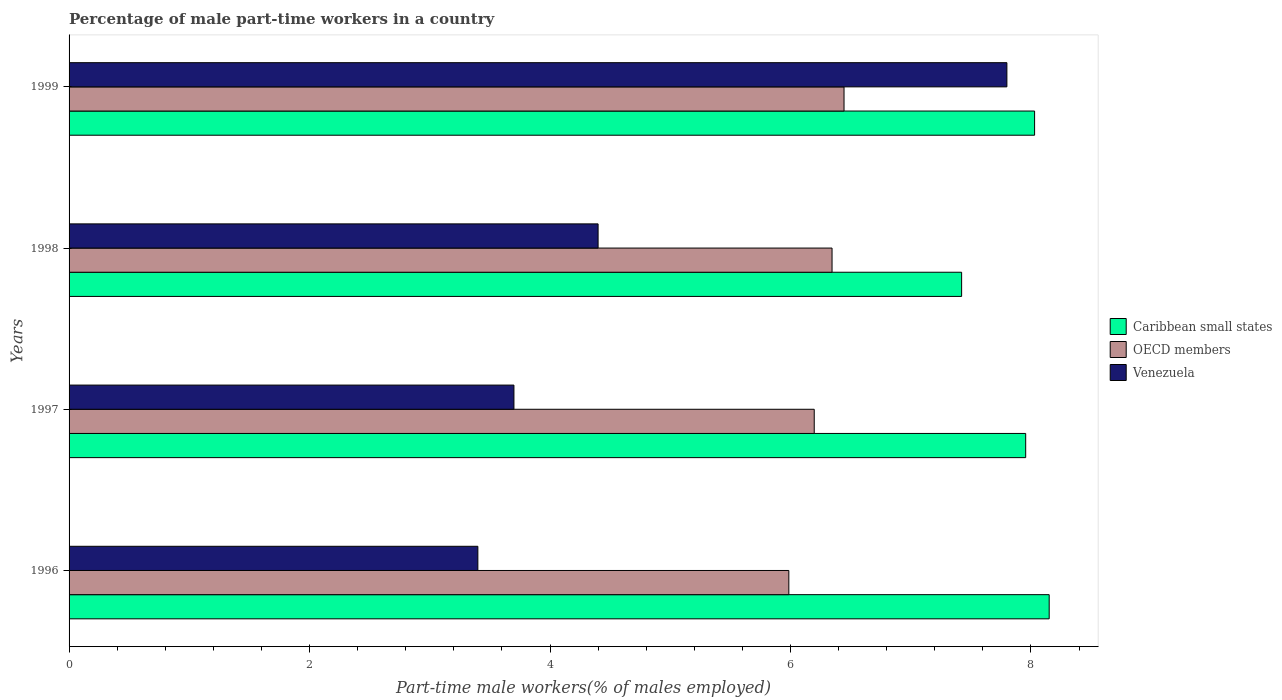How many different coloured bars are there?
Keep it short and to the point. 3. Are the number of bars per tick equal to the number of legend labels?
Your answer should be compact. Yes. How many bars are there on the 3rd tick from the top?
Your answer should be compact. 3. What is the label of the 4th group of bars from the top?
Your response must be concise. 1996. In how many cases, is the number of bars for a given year not equal to the number of legend labels?
Offer a terse response. 0. What is the percentage of male part-time workers in Caribbean small states in 1998?
Your response must be concise. 7.42. Across all years, what is the maximum percentage of male part-time workers in Caribbean small states?
Your answer should be compact. 8.15. Across all years, what is the minimum percentage of male part-time workers in OECD members?
Offer a very short reply. 5.99. In which year was the percentage of male part-time workers in Caribbean small states minimum?
Make the answer very short. 1998. What is the total percentage of male part-time workers in OECD members in the graph?
Your answer should be compact. 24.98. What is the difference between the percentage of male part-time workers in Caribbean small states in 1997 and that in 1999?
Offer a terse response. -0.07. What is the difference between the percentage of male part-time workers in Venezuela in 1997 and the percentage of male part-time workers in OECD members in 1998?
Your answer should be very brief. -2.65. What is the average percentage of male part-time workers in Venezuela per year?
Give a very brief answer. 4.83. In the year 1996, what is the difference between the percentage of male part-time workers in Caribbean small states and percentage of male part-time workers in OECD members?
Provide a succinct answer. 2.17. What is the ratio of the percentage of male part-time workers in Caribbean small states in 1997 to that in 1999?
Ensure brevity in your answer.  0.99. Is the percentage of male part-time workers in OECD members in 1997 less than that in 1999?
Give a very brief answer. Yes. What is the difference between the highest and the second highest percentage of male part-time workers in Venezuela?
Give a very brief answer. 3.4. What is the difference between the highest and the lowest percentage of male part-time workers in Venezuela?
Your answer should be very brief. 4.4. In how many years, is the percentage of male part-time workers in OECD members greater than the average percentage of male part-time workers in OECD members taken over all years?
Offer a terse response. 2. What does the 1st bar from the top in 1999 represents?
Your response must be concise. Venezuela. What does the 1st bar from the bottom in 1999 represents?
Provide a short and direct response. Caribbean small states. Is it the case that in every year, the sum of the percentage of male part-time workers in Venezuela and percentage of male part-time workers in OECD members is greater than the percentage of male part-time workers in Caribbean small states?
Your answer should be very brief. Yes. Are all the bars in the graph horizontal?
Your answer should be compact. Yes. What is the difference between two consecutive major ticks on the X-axis?
Offer a terse response. 2. Are the values on the major ticks of X-axis written in scientific E-notation?
Your answer should be compact. No. Does the graph contain grids?
Provide a short and direct response. No. How many legend labels are there?
Ensure brevity in your answer.  3. How are the legend labels stacked?
Your answer should be very brief. Vertical. What is the title of the graph?
Provide a short and direct response. Percentage of male part-time workers in a country. Does "Ghana" appear as one of the legend labels in the graph?
Offer a terse response. No. What is the label or title of the X-axis?
Offer a terse response. Part-time male workers(% of males employed). What is the label or title of the Y-axis?
Give a very brief answer. Years. What is the Part-time male workers(% of males employed) of Caribbean small states in 1996?
Offer a terse response. 8.15. What is the Part-time male workers(% of males employed) of OECD members in 1996?
Provide a succinct answer. 5.99. What is the Part-time male workers(% of males employed) of Venezuela in 1996?
Make the answer very short. 3.4. What is the Part-time male workers(% of males employed) of Caribbean small states in 1997?
Offer a very short reply. 7.96. What is the Part-time male workers(% of males employed) of OECD members in 1997?
Give a very brief answer. 6.2. What is the Part-time male workers(% of males employed) in Venezuela in 1997?
Your answer should be compact. 3.7. What is the Part-time male workers(% of males employed) in Caribbean small states in 1998?
Give a very brief answer. 7.42. What is the Part-time male workers(% of males employed) in OECD members in 1998?
Provide a succinct answer. 6.35. What is the Part-time male workers(% of males employed) of Venezuela in 1998?
Make the answer very short. 4.4. What is the Part-time male workers(% of males employed) of Caribbean small states in 1999?
Your answer should be compact. 8.03. What is the Part-time male workers(% of males employed) in OECD members in 1999?
Offer a very short reply. 6.45. What is the Part-time male workers(% of males employed) of Venezuela in 1999?
Your response must be concise. 7.8. Across all years, what is the maximum Part-time male workers(% of males employed) of Caribbean small states?
Provide a succinct answer. 8.15. Across all years, what is the maximum Part-time male workers(% of males employed) of OECD members?
Your response must be concise. 6.45. Across all years, what is the maximum Part-time male workers(% of males employed) of Venezuela?
Offer a terse response. 7.8. Across all years, what is the minimum Part-time male workers(% of males employed) in Caribbean small states?
Keep it short and to the point. 7.42. Across all years, what is the minimum Part-time male workers(% of males employed) of OECD members?
Your response must be concise. 5.99. Across all years, what is the minimum Part-time male workers(% of males employed) in Venezuela?
Your answer should be very brief. 3.4. What is the total Part-time male workers(% of males employed) of Caribbean small states in the graph?
Provide a succinct answer. 31.56. What is the total Part-time male workers(% of males employed) of OECD members in the graph?
Ensure brevity in your answer.  24.98. What is the total Part-time male workers(% of males employed) in Venezuela in the graph?
Offer a very short reply. 19.3. What is the difference between the Part-time male workers(% of males employed) of Caribbean small states in 1996 and that in 1997?
Your answer should be compact. 0.2. What is the difference between the Part-time male workers(% of males employed) in OECD members in 1996 and that in 1997?
Offer a terse response. -0.21. What is the difference between the Part-time male workers(% of males employed) of Venezuela in 1996 and that in 1997?
Offer a very short reply. -0.3. What is the difference between the Part-time male workers(% of males employed) of Caribbean small states in 1996 and that in 1998?
Your answer should be compact. 0.73. What is the difference between the Part-time male workers(% of males employed) of OECD members in 1996 and that in 1998?
Offer a terse response. -0.36. What is the difference between the Part-time male workers(% of males employed) of Venezuela in 1996 and that in 1998?
Your response must be concise. -1. What is the difference between the Part-time male workers(% of males employed) of Caribbean small states in 1996 and that in 1999?
Ensure brevity in your answer.  0.12. What is the difference between the Part-time male workers(% of males employed) of OECD members in 1996 and that in 1999?
Offer a terse response. -0.46. What is the difference between the Part-time male workers(% of males employed) of Venezuela in 1996 and that in 1999?
Ensure brevity in your answer.  -4.4. What is the difference between the Part-time male workers(% of males employed) in Caribbean small states in 1997 and that in 1998?
Your answer should be very brief. 0.53. What is the difference between the Part-time male workers(% of males employed) of OECD members in 1997 and that in 1998?
Your answer should be very brief. -0.15. What is the difference between the Part-time male workers(% of males employed) in Caribbean small states in 1997 and that in 1999?
Provide a short and direct response. -0.07. What is the difference between the Part-time male workers(% of males employed) in OECD members in 1997 and that in 1999?
Your answer should be very brief. -0.25. What is the difference between the Part-time male workers(% of males employed) of Venezuela in 1997 and that in 1999?
Keep it short and to the point. -4.1. What is the difference between the Part-time male workers(% of males employed) of Caribbean small states in 1998 and that in 1999?
Your response must be concise. -0.61. What is the difference between the Part-time male workers(% of males employed) in OECD members in 1998 and that in 1999?
Your response must be concise. -0.1. What is the difference between the Part-time male workers(% of males employed) of Caribbean small states in 1996 and the Part-time male workers(% of males employed) of OECD members in 1997?
Your answer should be very brief. 1.95. What is the difference between the Part-time male workers(% of males employed) in Caribbean small states in 1996 and the Part-time male workers(% of males employed) in Venezuela in 1997?
Offer a terse response. 4.45. What is the difference between the Part-time male workers(% of males employed) in OECD members in 1996 and the Part-time male workers(% of males employed) in Venezuela in 1997?
Provide a succinct answer. 2.29. What is the difference between the Part-time male workers(% of males employed) of Caribbean small states in 1996 and the Part-time male workers(% of males employed) of OECD members in 1998?
Provide a short and direct response. 1.81. What is the difference between the Part-time male workers(% of males employed) in Caribbean small states in 1996 and the Part-time male workers(% of males employed) in Venezuela in 1998?
Make the answer very short. 3.75. What is the difference between the Part-time male workers(% of males employed) of OECD members in 1996 and the Part-time male workers(% of males employed) of Venezuela in 1998?
Provide a succinct answer. 1.59. What is the difference between the Part-time male workers(% of males employed) of Caribbean small states in 1996 and the Part-time male workers(% of males employed) of OECD members in 1999?
Make the answer very short. 1.71. What is the difference between the Part-time male workers(% of males employed) in Caribbean small states in 1996 and the Part-time male workers(% of males employed) in Venezuela in 1999?
Your response must be concise. 0.35. What is the difference between the Part-time male workers(% of males employed) of OECD members in 1996 and the Part-time male workers(% of males employed) of Venezuela in 1999?
Offer a terse response. -1.81. What is the difference between the Part-time male workers(% of males employed) in Caribbean small states in 1997 and the Part-time male workers(% of males employed) in OECD members in 1998?
Your answer should be compact. 1.61. What is the difference between the Part-time male workers(% of males employed) in Caribbean small states in 1997 and the Part-time male workers(% of males employed) in Venezuela in 1998?
Give a very brief answer. 3.56. What is the difference between the Part-time male workers(% of males employed) of OECD members in 1997 and the Part-time male workers(% of males employed) of Venezuela in 1998?
Your response must be concise. 1.8. What is the difference between the Part-time male workers(% of males employed) of Caribbean small states in 1997 and the Part-time male workers(% of males employed) of OECD members in 1999?
Your response must be concise. 1.51. What is the difference between the Part-time male workers(% of males employed) of Caribbean small states in 1997 and the Part-time male workers(% of males employed) of Venezuela in 1999?
Ensure brevity in your answer.  0.16. What is the difference between the Part-time male workers(% of males employed) of OECD members in 1997 and the Part-time male workers(% of males employed) of Venezuela in 1999?
Provide a short and direct response. -1.6. What is the difference between the Part-time male workers(% of males employed) in Caribbean small states in 1998 and the Part-time male workers(% of males employed) in Venezuela in 1999?
Give a very brief answer. -0.38. What is the difference between the Part-time male workers(% of males employed) of OECD members in 1998 and the Part-time male workers(% of males employed) of Venezuela in 1999?
Provide a short and direct response. -1.45. What is the average Part-time male workers(% of males employed) of Caribbean small states per year?
Provide a succinct answer. 7.89. What is the average Part-time male workers(% of males employed) of OECD members per year?
Provide a succinct answer. 6.24. What is the average Part-time male workers(% of males employed) of Venezuela per year?
Keep it short and to the point. 4.83. In the year 1996, what is the difference between the Part-time male workers(% of males employed) of Caribbean small states and Part-time male workers(% of males employed) of OECD members?
Offer a terse response. 2.17. In the year 1996, what is the difference between the Part-time male workers(% of males employed) in Caribbean small states and Part-time male workers(% of males employed) in Venezuela?
Offer a terse response. 4.75. In the year 1996, what is the difference between the Part-time male workers(% of males employed) in OECD members and Part-time male workers(% of males employed) in Venezuela?
Make the answer very short. 2.59. In the year 1997, what is the difference between the Part-time male workers(% of males employed) of Caribbean small states and Part-time male workers(% of males employed) of OECD members?
Make the answer very short. 1.76. In the year 1997, what is the difference between the Part-time male workers(% of males employed) in Caribbean small states and Part-time male workers(% of males employed) in Venezuela?
Offer a very short reply. 4.26. In the year 1997, what is the difference between the Part-time male workers(% of males employed) in OECD members and Part-time male workers(% of males employed) in Venezuela?
Offer a very short reply. 2.5. In the year 1998, what is the difference between the Part-time male workers(% of males employed) in Caribbean small states and Part-time male workers(% of males employed) in OECD members?
Offer a very short reply. 1.08. In the year 1998, what is the difference between the Part-time male workers(% of males employed) of Caribbean small states and Part-time male workers(% of males employed) of Venezuela?
Ensure brevity in your answer.  3.02. In the year 1998, what is the difference between the Part-time male workers(% of males employed) in OECD members and Part-time male workers(% of males employed) in Venezuela?
Your response must be concise. 1.95. In the year 1999, what is the difference between the Part-time male workers(% of males employed) of Caribbean small states and Part-time male workers(% of males employed) of OECD members?
Provide a short and direct response. 1.58. In the year 1999, what is the difference between the Part-time male workers(% of males employed) of Caribbean small states and Part-time male workers(% of males employed) of Venezuela?
Your answer should be compact. 0.23. In the year 1999, what is the difference between the Part-time male workers(% of males employed) of OECD members and Part-time male workers(% of males employed) of Venezuela?
Provide a short and direct response. -1.35. What is the ratio of the Part-time male workers(% of males employed) in Caribbean small states in 1996 to that in 1997?
Give a very brief answer. 1.02. What is the ratio of the Part-time male workers(% of males employed) in OECD members in 1996 to that in 1997?
Provide a succinct answer. 0.97. What is the ratio of the Part-time male workers(% of males employed) in Venezuela in 1996 to that in 1997?
Provide a short and direct response. 0.92. What is the ratio of the Part-time male workers(% of males employed) in Caribbean small states in 1996 to that in 1998?
Give a very brief answer. 1.1. What is the ratio of the Part-time male workers(% of males employed) in OECD members in 1996 to that in 1998?
Make the answer very short. 0.94. What is the ratio of the Part-time male workers(% of males employed) in Venezuela in 1996 to that in 1998?
Keep it short and to the point. 0.77. What is the ratio of the Part-time male workers(% of males employed) of Caribbean small states in 1996 to that in 1999?
Offer a terse response. 1.02. What is the ratio of the Part-time male workers(% of males employed) of OECD members in 1996 to that in 1999?
Your response must be concise. 0.93. What is the ratio of the Part-time male workers(% of males employed) in Venezuela in 1996 to that in 1999?
Keep it short and to the point. 0.44. What is the ratio of the Part-time male workers(% of males employed) in Caribbean small states in 1997 to that in 1998?
Make the answer very short. 1.07. What is the ratio of the Part-time male workers(% of males employed) of OECD members in 1997 to that in 1998?
Offer a very short reply. 0.98. What is the ratio of the Part-time male workers(% of males employed) in Venezuela in 1997 to that in 1998?
Your answer should be very brief. 0.84. What is the ratio of the Part-time male workers(% of males employed) in Caribbean small states in 1997 to that in 1999?
Ensure brevity in your answer.  0.99. What is the ratio of the Part-time male workers(% of males employed) in OECD members in 1997 to that in 1999?
Provide a succinct answer. 0.96. What is the ratio of the Part-time male workers(% of males employed) in Venezuela in 1997 to that in 1999?
Provide a succinct answer. 0.47. What is the ratio of the Part-time male workers(% of males employed) of Caribbean small states in 1998 to that in 1999?
Give a very brief answer. 0.92. What is the ratio of the Part-time male workers(% of males employed) of OECD members in 1998 to that in 1999?
Keep it short and to the point. 0.98. What is the ratio of the Part-time male workers(% of males employed) of Venezuela in 1998 to that in 1999?
Offer a very short reply. 0.56. What is the difference between the highest and the second highest Part-time male workers(% of males employed) in Caribbean small states?
Provide a short and direct response. 0.12. What is the difference between the highest and the second highest Part-time male workers(% of males employed) in OECD members?
Your response must be concise. 0.1. What is the difference between the highest and the lowest Part-time male workers(% of males employed) in Caribbean small states?
Keep it short and to the point. 0.73. What is the difference between the highest and the lowest Part-time male workers(% of males employed) of OECD members?
Your answer should be very brief. 0.46. 